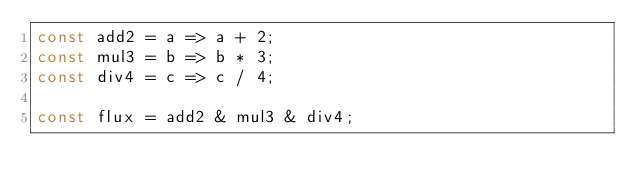<code> <loc_0><loc_0><loc_500><loc_500><_JavaScript_>const add2 = a => a + 2;
const mul3 = b => b * 3;
const div4 = c => c / 4;

const flux = add2 & mul3 & div4;
</code> 